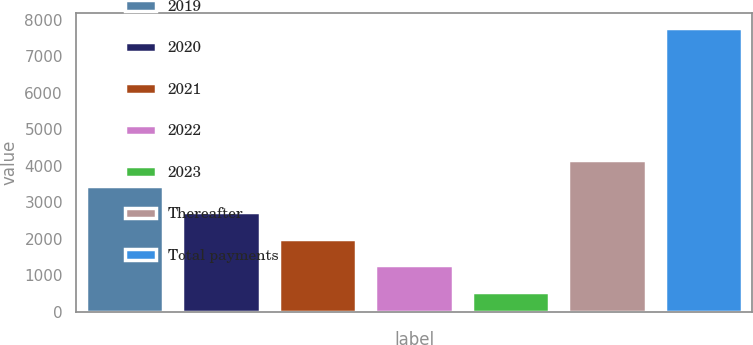Convert chart. <chart><loc_0><loc_0><loc_500><loc_500><bar_chart><fcel>2019<fcel>2020<fcel>2021<fcel>2022<fcel>2023<fcel>Thereafter<fcel>Total payments<nl><fcel>3447.8<fcel>2724.6<fcel>2001.4<fcel>1278.2<fcel>555<fcel>4171<fcel>7787<nl></chart> 